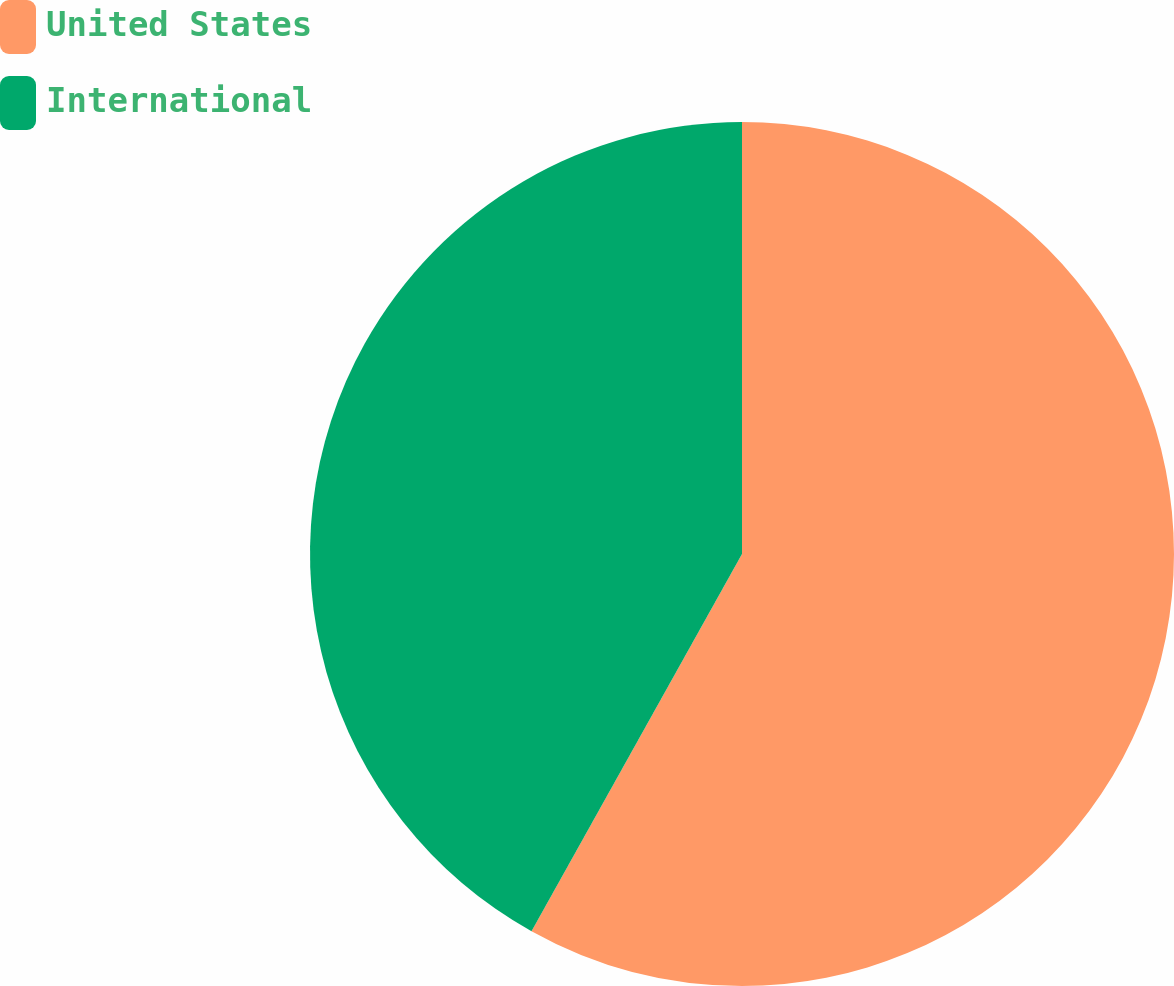<chart> <loc_0><loc_0><loc_500><loc_500><pie_chart><fcel>United States<fcel>International<nl><fcel>58.1%<fcel>41.9%<nl></chart> 